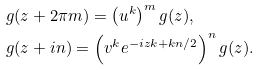<formula> <loc_0><loc_0><loc_500><loc_500>& g ( z + 2 \pi m ) = \left ( u ^ { k } \right ) ^ { m } g ( z ) , \\ & g ( z + i n ) = \left ( v ^ { k } e ^ { - i z k + k n / 2 } \right ) ^ { n } g ( z ) .</formula> 